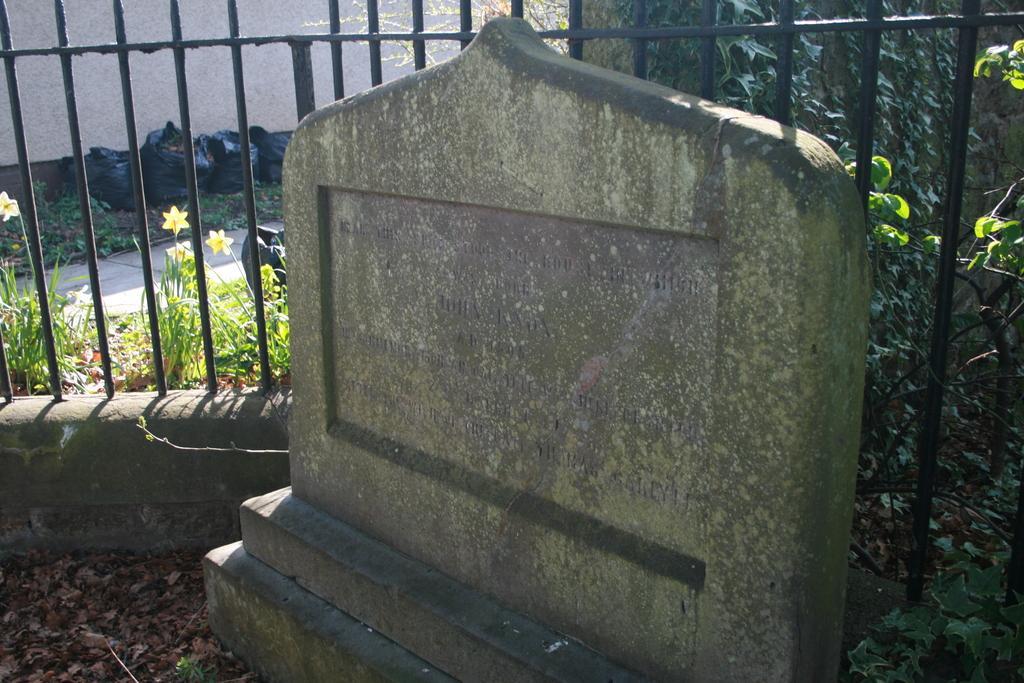Could you give a brief overview of what you see in this image? In this image I can see a stone with some text written on it. In the background, I can see the rail. I can see the flowers and the polythene covers. 